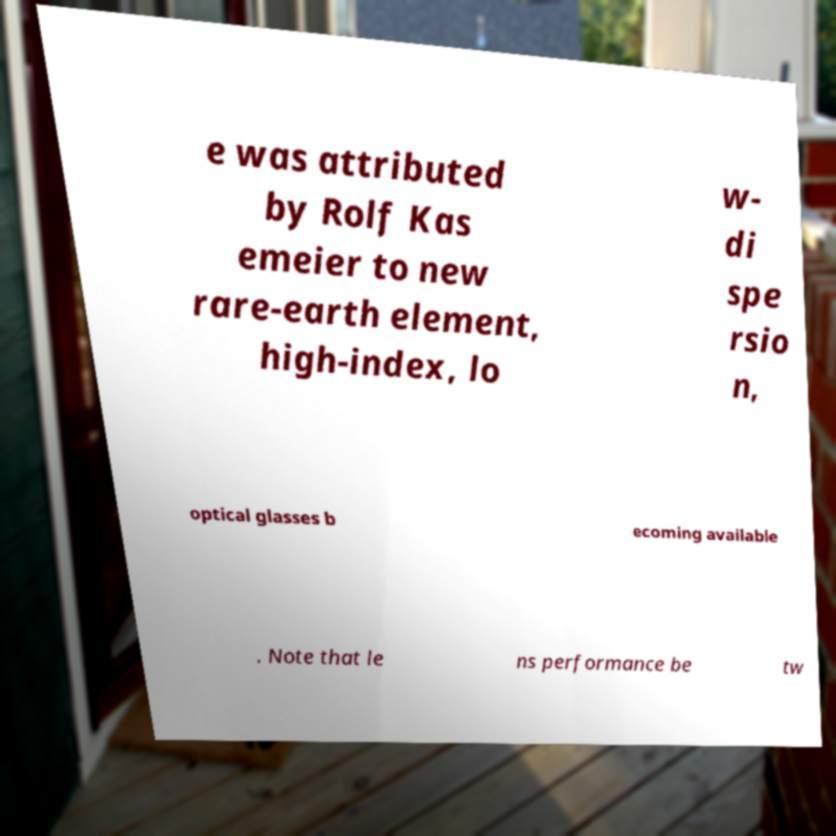I need the written content from this picture converted into text. Can you do that? e was attributed by Rolf Kas emeier to new rare-earth element, high-index, lo w- di spe rsio n, optical glasses b ecoming available . Note that le ns performance be tw 